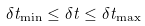<formula> <loc_0><loc_0><loc_500><loc_500>\delta t _ { \min } \leq \delta t \leq \delta t _ { \max }</formula> 